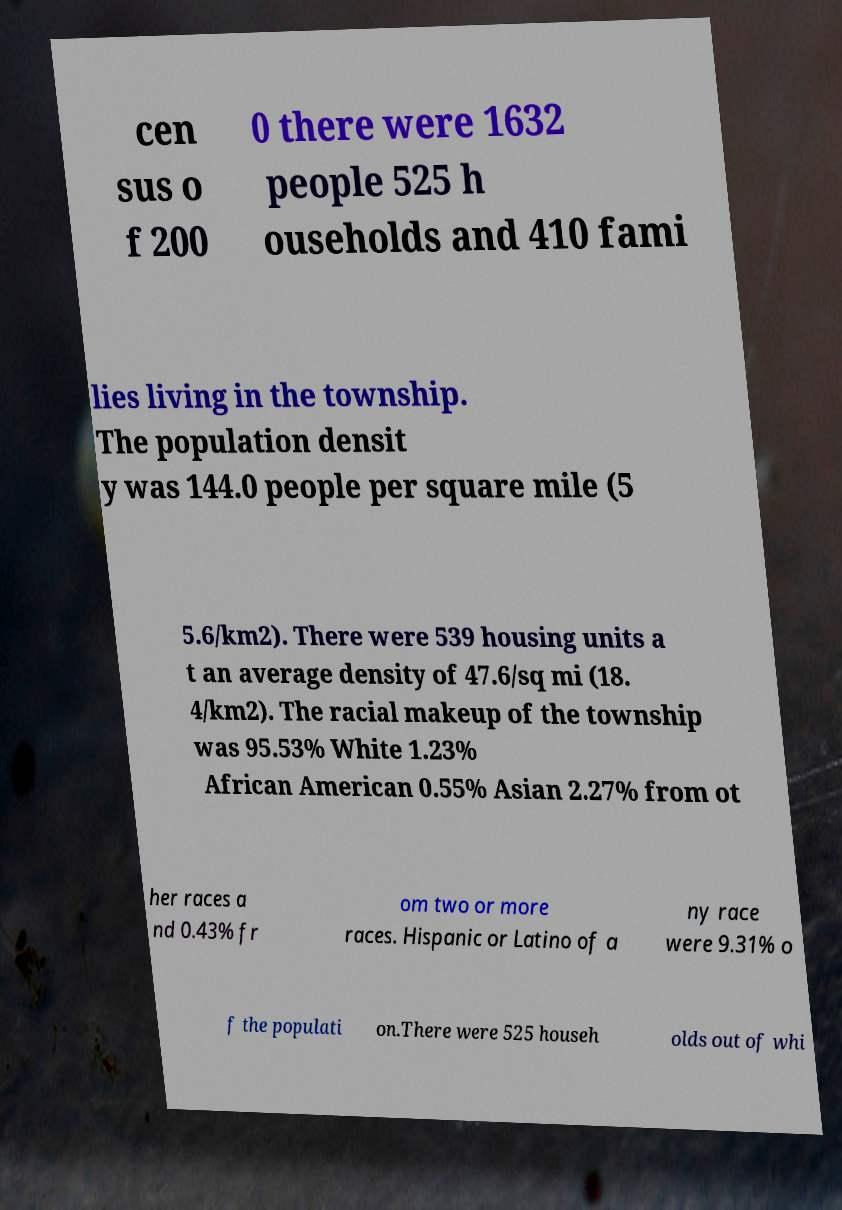There's text embedded in this image that I need extracted. Can you transcribe it verbatim? cen sus o f 200 0 there were 1632 people 525 h ouseholds and 410 fami lies living in the township. The population densit y was 144.0 people per square mile (5 5.6/km2). There were 539 housing units a t an average density of 47.6/sq mi (18. 4/km2). The racial makeup of the township was 95.53% White 1.23% African American 0.55% Asian 2.27% from ot her races a nd 0.43% fr om two or more races. Hispanic or Latino of a ny race were 9.31% o f the populati on.There were 525 househ olds out of whi 